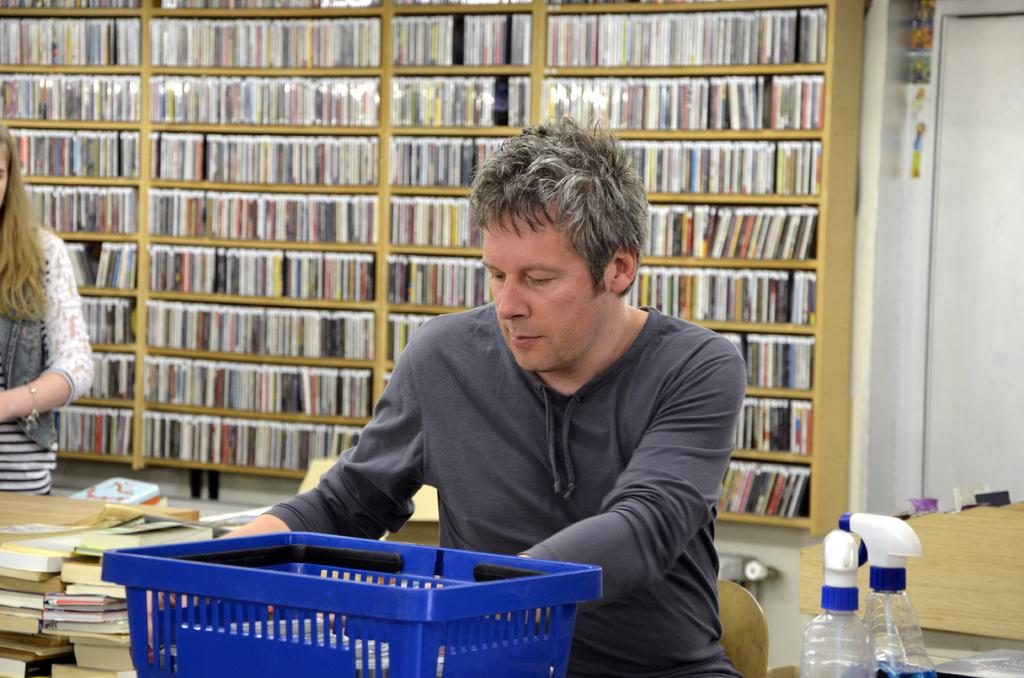What is the main subject in the center of the image? There is a man sitting on a chair in the center of the image. What can be seen in the background of the image? There is a bookshelf in the background of the image. Who else is present in the image? There is a girl on the left side of the image. What type of eggnog is being served in the image? There is no eggnog present in the image. What is the purpose of the bedroom in the image? The image does not depict a bedroom, so it is not possible to determine the purpose of a bedroom in this context. 